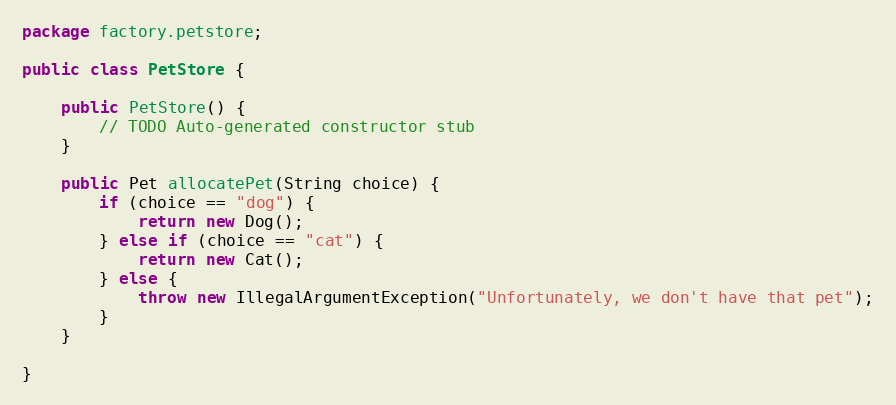<code> <loc_0><loc_0><loc_500><loc_500><_Java_>package factory.petstore;

public class PetStore {

	public PetStore() {
		// TODO Auto-generated constructor stub
	}

	public Pet allocatePet(String choice) {
		if (choice == "dog") {
			return new Dog();
		} else if (choice == "cat") {
			return new Cat();
		} else {
			throw new IllegalArgumentException("Unfortunately, we don't have that pet");
		}
	}

}
</code> 